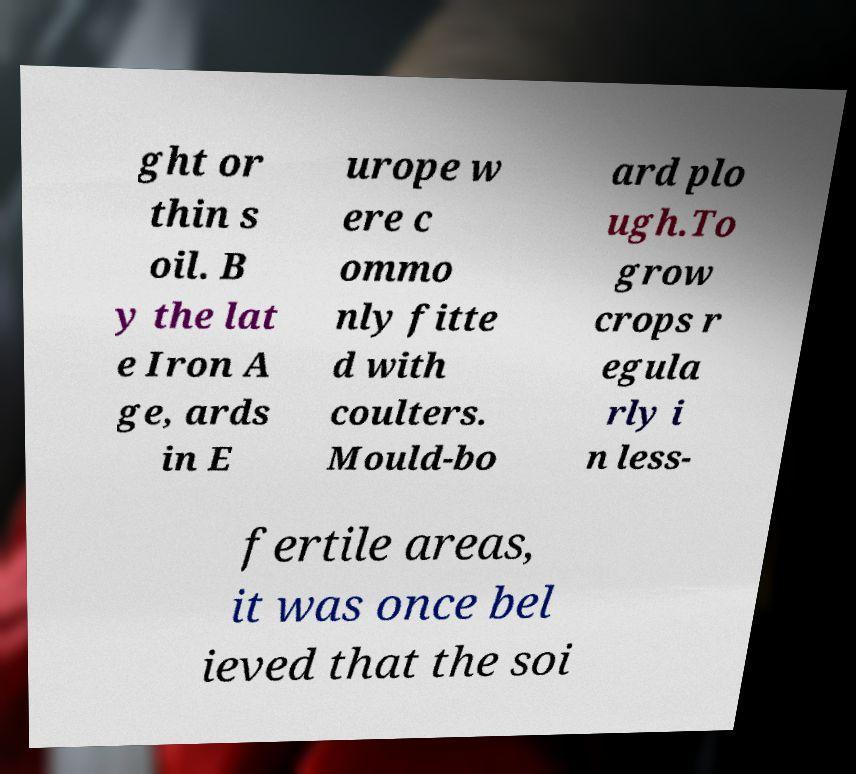Can you read and provide the text displayed in the image?This photo seems to have some interesting text. Can you extract and type it out for me? ght or thin s oil. B y the lat e Iron A ge, ards in E urope w ere c ommo nly fitte d with coulters. Mould-bo ard plo ugh.To grow crops r egula rly i n less- fertile areas, it was once bel ieved that the soi 